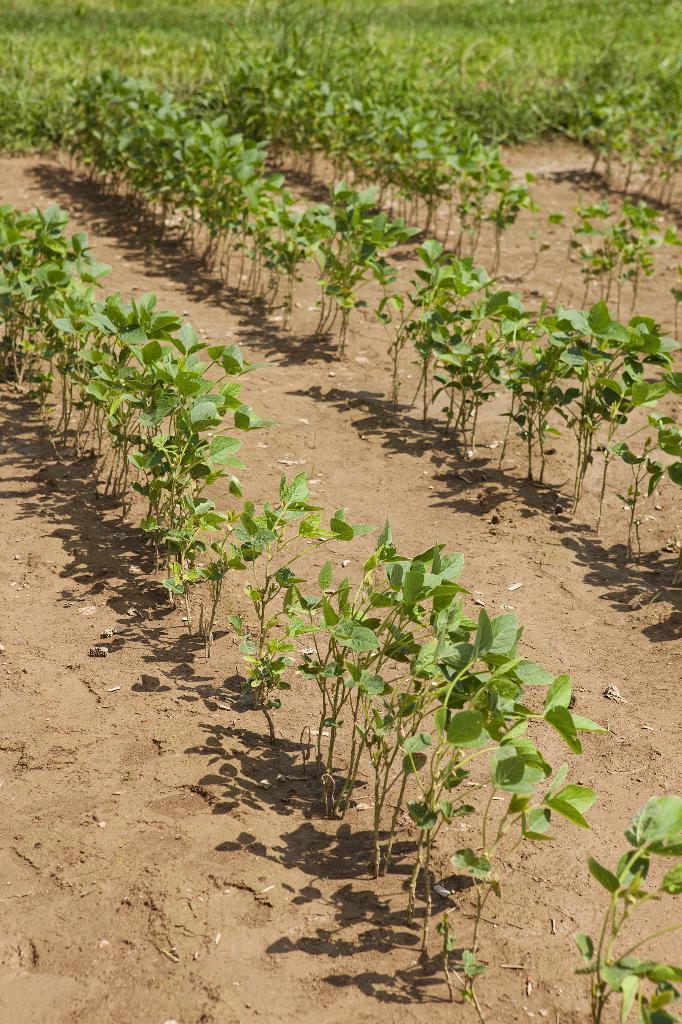Could you give a brief overview of what you see in this image? In this image, I think these are the plants with the leaves. These leaves are green in color. 